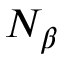<formula> <loc_0><loc_0><loc_500><loc_500>N _ { \beta }</formula> 